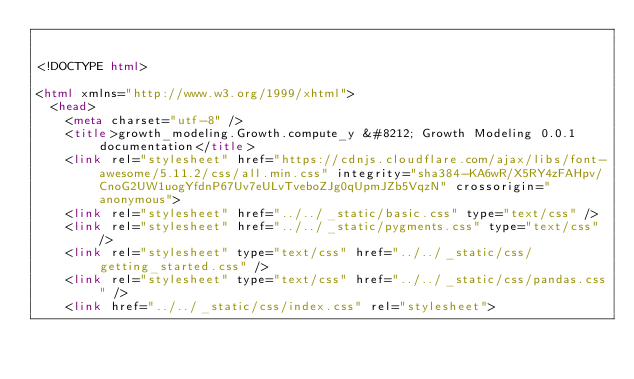Convert code to text. <code><loc_0><loc_0><loc_500><loc_500><_HTML_>

<!DOCTYPE html>

<html xmlns="http://www.w3.org/1999/xhtml">
  <head>
    <meta charset="utf-8" />
    <title>growth_modeling.Growth.compute_y &#8212; Growth Modeling 0.0.1 documentation</title>
    <link rel="stylesheet" href="https://cdnjs.cloudflare.com/ajax/libs/font-awesome/5.11.2/css/all.min.css" integrity="sha384-KA6wR/X5RY4zFAHpv/CnoG2UW1uogYfdnP67Uv7eULvTveboZJg0qUpmJZb5VqzN" crossorigin="anonymous">
    <link rel="stylesheet" href="../../_static/basic.css" type="text/css" />
    <link rel="stylesheet" href="../../_static/pygments.css" type="text/css" />
    <link rel="stylesheet" type="text/css" href="../../_static/css/getting_started.css" />
    <link rel="stylesheet" type="text/css" href="../../_static/css/pandas.css" />
    <link href="../../_static/css/index.css" rel="stylesheet"></code> 